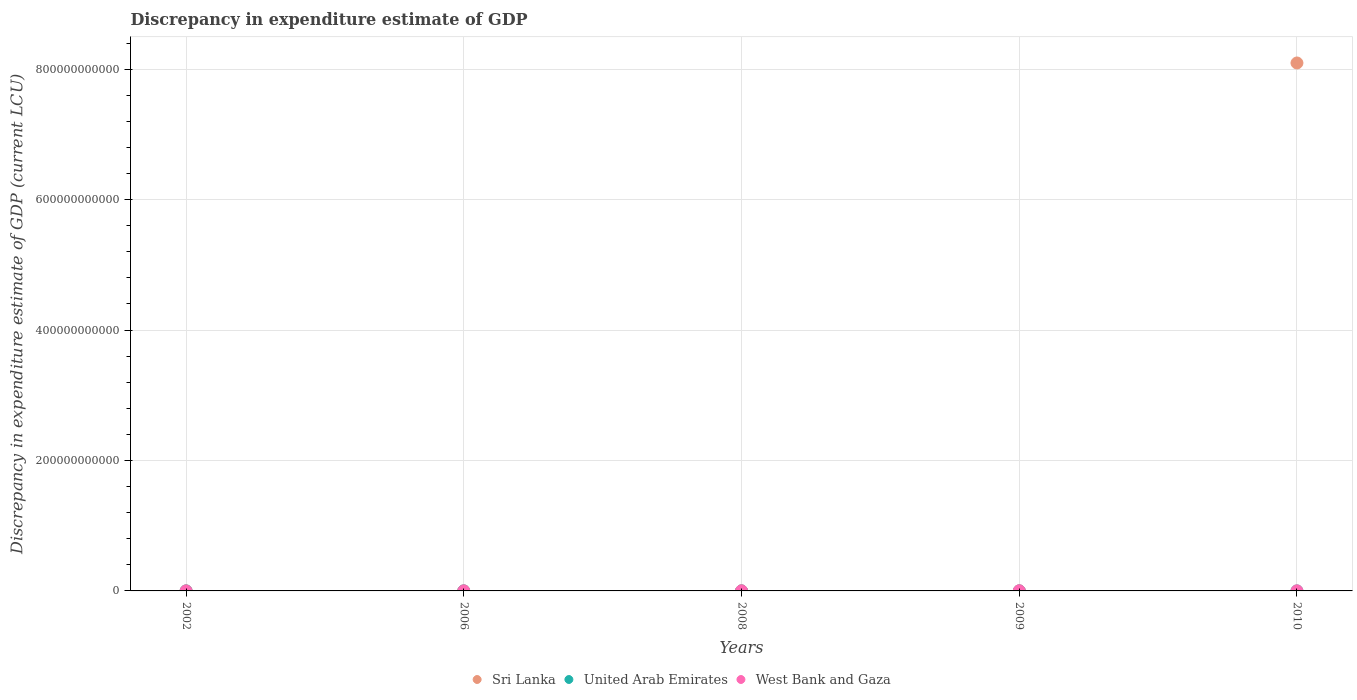How many different coloured dotlines are there?
Give a very brief answer. 3. What is the discrepancy in expenditure estimate of GDP in West Bank and Gaza in 2010?
Make the answer very short. 1.23e+08. Across all years, what is the maximum discrepancy in expenditure estimate of GDP in United Arab Emirates?
Offer a very short reply. 1.00e+06. Across all years, what is the minimum discrepancy in expenditure estimate of GDP in United Arab Emirates?
Make the answer very short. 0. In which year was the discrepancy in expenditure estimate of GDP in United Arab Emirates maximum?
Offer a very short reply. 2006. What is the total discrepancy in expenditure estimate of GDP in Sri Lanka in the graph?
Your answer should be compact. 8.10e+11. What is the difference between the discrepancy in expenditure estimate of GDP in West Bank and Gaza in 2006 and that in 2008?
Your response must be concise. -8.52e+07. What is the difference between the discrepancy in expenditure estimate of GDP in Sri Lanka in 2009 and the discrepancy in expenditure estimate of GDP in United Arab Emirates in 2008?
Keep it short and to the point. 1.00e+06. What is the average discrepancy in expenditure estimate of GDP in West Bank and Gaza per year?
Ensure brevity in your answer.  9.94e+07. In the year 2009, what is the difference between the discrepancy in expenditure estimate of GDP in West Bank and Gaza and discrepancy in expenditure estimate of GDP in Sri Lanka?
Ensure brevity in your answer.  2.21e+08. What is the ratio of the discrepancy in expenditure estimate of GDP in United Arab Emirates in 2002 to that in 2009?
Ensure brevity in your answer.  0.13. What is the difference between the highest and the second highest discrepancy in expenditure estimate of GDP in United Arab Emirates?
Offer a terse response. 1.00e+06. What is the difference between the highest and the lowest discrepancy in expenditure estimate of GDP in United Arab Emirates?
Keep it short and to the point. 1.00e+06. In how many years, is the discrepancy in expenditure estimate of GDP in West Bank and Gaza greater than the average discrepancy in expenditure estimate of GDP in West Bank and Gaza taken over all years?
Offer a very short reply. 3. Is it the case that in every year, the sum of the discrepancy in expenditure estimate of GDP in West Bank and Gaza and discrepancy in expenditure estimate of GDP in Sri Lanka  is greater than the discrepancy in expenditure estimate of GDP in United Arab Emirates?
Your answer should be compact. Yes. Does the discrepancy in expenditure estimate of GDP in West Bank and Gaza monotonically increase over the years?
Offer a very short reply. No. How many dotlines are there?
Your answer should be compact. 3. How many years are there in the graph?
Offer a terse response. 5. What is the difference between two consecutive major ticks on the Y-axis?
Make the answer very short. 2.00e+11. Are the values on the major ticks of Y-axis written in scientific E-notation?
Your answer should be compact. No. Does the graph contain grids?
Keep it short and to the point. Yes. Where does the legend appear in the graph?
Offer a terse response. Bottom center. What is the title of the graph?
Ensure brevity in your answer.  Discrepancy in expenditure estimate of GDP. What is the label or title of the Y-axis?
Make the answer very short. Discrepancy in expenditure estimate of GDP (current LCU). What is the Discrepancy in expenditure estimate of GDP (current LCU) in Sri Lanka in 2002?
Offer a terse response. 0. What is the Discrepancy in expenditure estimate of GDP (current LCU) in United Arab Emirates in 2002?
Provide a short and direct response. 3e-5. What is the Discrepancy in expenditure estimate of GDP (current LCU) of West Bank and Gaza in 2002?
Keep it short and to the point. 0. What is the Discrepancy in expenditure estimate of GDP (current LCU) in Sri Lanka in 2006?
Your answer should be compact. 0. What is the Discrepancy in expenditure estimate of GDP (current LCU) of United Arab Emirates in 2006?
Your response must be concise. 1.00e+06. What is the Discrepancy in expenditure estimate of GDP (current LCU) of West Bank and Gaza in 2006?
Keep it short and to the point. 3.30e+07. What is the Discrepancy in expenditure estimate of GDP (current LCU) in West Bank and Gaza in 2008?
Offer a very short reply. 1.18e+08. What is the Discrepancy in expenditure estimate of GDP (current LCU) of Sri Lanka in 2009?
Keep it short and to the point. 1.00e+06. What is the Discrepancy in expenditure estimate of GDP (current LCU) of United Arab Emirates in 2009?
Your response must be concise. 0. What is the Discrepancy in expenditure estimate of GDP (current LCU) in West Bank and Gaza in 2009?
Your response must be concise. 2.22e+08. What is the Discrepancy in expenditure estimate of GDP (current LCU) in Sri Lanka in 2010?
Give a very brief answer. 8.10e+11. What is the Discrepancy in expenditure estimate of GDP (current LCU) in West Bank and Gaza in 2010?
Give a very brief answer. 1.23e+08. Across all years, what is the maximum Discrepancy in expenditure estimate of GDP (current LCU) in Sri Lanka?
Keep it short and to the point. 8.10e+11. Across all years, what is the maximum Discrepancy in expenditure estimate of GDP (current LCU) in United Arab Emirates?
Give a very brief answer. 1.00e+06. Across all years, what is the maximum Discrepancy in expenditure estimate of GDP (current LCU) of West Bank and Gaza?
Ensure brevity in your answer.  2.22e+08. What is the total Discrepancy in expenditure estimate of GDP (current LCU) in Sri Lanka in the graph?
Your answer should be very brief. 8.10e+11. What is the total Discrepancy in expenditure estimate of GDP (current LCU) of United Arab Emirates in the graph?
Your answer should be very brief. 1.00e+06. What is the total Discrepancy in expenditure estimate of GDP (current LCU) of West Bank and Gaza in the graph?
Give a very brief answer. 4.97e+08. What is the difference between the Discrepancy in expenditure estimate of GDP (current LCU) in Sri Lanka in 2002 and that in 2006?
Your answer should be compact. -0. What is the difference between the Discrepancy in expenditure estimate of GDP (current LCU) of United Arab Emirates in 2002 and that in 2006?
Give a very brief answer. -1.00e+06. What is the difference between the Discrepancy in expenditure estimate of GDP (current LCU) of Sri Lanka in 2002 and that in 2009?
Provide a succinct answer. -1.00e+06. What is the difference between the Discrepancy in expenditure estimate of GDP (current LCU) in United Arab Emirates in 2002 and that in 2009?
Keep it short and to the point. -0. What is the difference between the Discrepancy in expenditure estimate of GDP (current LCU) in Sri Lanka in 2002 and that in 2010?
Offer a terse response. -8.10e+11. What is the difference between the Discrepancy in expenditure estimate of GDP (current LCU) of West Bank and Gaza in 2006 and that in 2008?
Provide a short and direct response. -8.52e+07. What is the difference between the Discrepancy in expenditure estimate of GDP (current LCU) in Sri Lanka in 2006 and that in 2009?
Your answer should be very brief. -1.00e+06. What is the difference between the Discrepancy in expenditure estimate of GDP (current LCU) in United Arab Emirates in 2006 and that in 2009?
Offer a very short reply. 1.00e+06. What is the difference between the Discrepancy in expenditure estimate of GDP (current LCU) in West Bank and Gaza in 2006 and that in 2009?
Provide a short and direct response. -1.89e+08. What is the difference between the Discrepancy in expenditure estimate of GDP (current LCU) of Sri Lanka in 2006 and that in 2010?
Provide a short and direct response. -8.10e+11. What is the difference between the Discrepancy in expenditure estimate of GDP (current LCU) in West Bank and Gaza in 2006 and that in 2010?
Keep it short and to the point. -9.05e+07. What is the difference between the Discrepancy in expenditure estimate of GDP (current LCU) in West Bank and Gaza in 2008 and that in 2009?
Your response must be concise. -1.04e+08. What is the difference between the Discrepancy in expenditure estimate of GDP (current LCU) in West Bank and Gaza in 2008 and that in 2010?
Provide a short and direct response. -5.23e+06. What is the difference between the Discrepancy in expenditure estimate of GDP (current LCU) of Sri Lanka in 2009 and that in 2010?
Your answer should be compact. -8.10e+11. What is the difference between the Discrepancy in expenditure estimate of GDP (current LCU) of West Bank and Gaza in 2009 and that in 2010?
Provide a succinct answer. 9.88e+07. What is the difference between the Discrepancy in expenditure estimate of GDP (current LCU) in Sri Lanka in 2002 and the Discrepancy in expenditure estimate of GDP (current LCU) in United Arab Emirates in 2006?
Provide a short and direct response. -1.00e+06. What is the difference between the Discrepancy in expenditure estimate of GDP (current LCU) of Sri Lanka in 2002 and the Discrepancy in expenditure estimate of GDP (current LCU) of West Bank and Gaza in 2006?
Your response must be concise. -3.30e+07. What is the difference between the Discrepancy in expenditure estimate of GDP (current LCU) in United Arab Emirates in 2002 and the Discrepancy in expenditure estimate of GDP (current LCU) in West Bank and Gaza in 2006?
Offer a very short reply. -3.30e+07. What is the difference between the Discrepancy in expenditure estimate of GDP (current LCU) of Sri Lanka in 2002 and the Discrepancy in expenditure estimate of GDP (current LCU) of West Bank and Gaza in 2008?
Offer a very short reply. -1.18e+08. What is the difference between the Discrepancy in expenditure estimate of GDP (current LCU) of United Arab Emirates in 2002 and the Discrepancy in expenditure estimate of GDP (current LCU) of West Bank and Gaza in 2008?
Your answer should be very brief. -1.18e+08. What is the difference between the Discrepancy in expenditure estimate of GDP (current LCU) of Sri Lanka in 2002 and the Discrepancy in expenditure estimate of GDP (current LCU) of United Arab Emirates in 2009?
Provide a succinct answer. -0. What is the difference between the Discrepancy in expenditure estimate of GDP (current LCU) in Sri Lanka in 2002 and the Discrepancy in expenditure estimate of GDP (current LCU) in West Bank and Gaza in 2009?
Offer a terse response. -2.22e+08. What is the difference between the Discrepancy in expenditure estimate of GDP (current LCU) of United Arab Emirates in 2002 and the Discrepancy in expenditure estimate of GDP (current LCU) of West Bank and Gaza in 2009?
Provide a short and direct response. -2.22e+08. What is the difference between the Discrepancy in expenditure estimate of GDP (current LCU) of Sri Lanka in 2002 and the Discrepancy in expenditure estimate of GDP (current LCU) of West Bank and Gaza in 2010?
Ensure brevity in your answer.  -1.23e+08. What is the difference between the Discrepancy in expenditure estimate of GDP (current LCU) of United Arab Emirates in 2002 and the Discrepancy in expenditure estimate of GDP (current LCU) of West Bank and Gaza in 2010?
Provide a succinct answer. -1.23e+08. What is the difference between the Discrepancy in expenditure estimate of GDP (current LCU) in Sri Lanka in 2006 and the Discrepancy in expenditure estimate of GDP (current LCU) in West Bank and Gaza in 2008?
Provide a short and direct response. -1.18e+08. What is the difference between the Discrepancy in expenditure estimate of GDP (current LCU) in United Arab Emirates in 2006 and the Discrepancy in expenditure estimate of GDP (current LCU) in West Bank and Gaza in 2008?
Ensure brevity in your answer.  -1.17e+08. What is the difference between the Discrepancy in expenditure estimate of GDP (current LCU) in Sri Lanka in 2006 and the Discrepancy in expenditure estimate of GDP (current LCU) in West Bank and Gaza in 2009?
Give a very brief answer. -2.22e+08. What is the difference between the Discrepancy in expenditure estimate of GDP (current LCU) of United Arab Emirates in 2006 and the Discrepancy in expenditure estimate of GDP (current LCU) of West Bank and Gaza in 2009?
Offer a terse response. -2.21e+08. What is the difference between the Discrepancy in expenditure estimate of GDP (current LCU) of Sri Lanka in 2006 and the Discrepancy in expenditure estimate of GDP (current LCU) of West Bank and Gaza in 2010?
Give a very brief answer. -1.23e+08. What is the difference between the Discrepancy in expenditure estimate of GDP (current LCU) in United Arab Emirates in 2006 and the Discrepancy in expenditure estimate of GDP (current LCU) in West Bank and Gaza in 2010?
Give a very brief answer. -1.22e+08. What is the difference between the Discrepancy in expenditure estimate of GDP (current LCU) of Sri Lanka in 2009 and the Discrepancy in expenditure estimate of GDP (current LCU) of West Bank and Gaza in 2010?
Provide a short and direct response. -1.22e+08. What is the difference between the Discrepancy in expenditure estimate of GDP (current LCU) in United Arab Emirates in 2009 and the Discrepancy in expenditure estimate of GDP (current LCU) in West Bank and Gaza in 2010?
Your answer should be very brief. -1.23e+08. What is the average Discrepancy in expenditure estimate of GDP (current LCU) in Sri Lanka per year?
Keep it short and to the point. 1.62e+11. What is the average Discrepancy in expenditure estimate of GDP (current LCU) in United Arab Emirates per year?
Your answer should be compact. 2.00e+05. What is the average Discrepancy in expenditure estimate of GDP (current LCU) of West Bank and Gaza per year?
Make the answer very short. 9.94e+07. In the year 2002, what is the difference between the Discrepancy in expenditure estimate of GDP (current LCU) of Sri Lanka and Discrepancy in expenditure estimate of GDP (current LCU) of United Arab Emirates?
Provide a succinct answer. 0. In the year 2006, what is the difference between the Discrepancy in expenditure estimate of GDP (current LCU) in Sri Lanka and Discrepancy in expenditure estimate of GDP (current LCU) in United Arab Emirates?
Provide a succinct answer. -1.00e+06. In the year 2006, what is the difference between the Discrepancy in expenditure estimate of GDP (current LCU) in Sri Lanka and Discrepancy in expenditure estimate of GDP (current LCU) in West Bank and Gaza?
Keep it short and to the point. -3.30e+07. In the year 2006, what is the difference between the Discrepancy in expenditure estimate of GDP (current LCU) of United Arab Emirates and Discrepancy in expenditure estimate of GDP (current LCU) of West Bank and Gaza?
Your response must be concise. -3.20e+07. In the year 2009, what is the difference between the Discrepancy in expenditure estimate of GDP (current LCU) in Sri Lanka and Discrepancy in expenditure estimate of GDP (current LCU) in United Arab Emirates?
Your answer should be compact. 1.00e+06. In the year 2009, what is the difference between the Discrepancy in expenditure estimate of GDP (current LCU) in Sri Lanka and Discrepancy in expenditure estimate of GDP (current LCU) in West Bank and Gaza?
Your response must be concise. -2.21e+08. In the year 2009, what is the difference between the Discrepancy in expenditure estimate of GDP (current LCU) in United Arab Emirates and Discrepancy in expenditure estimate of GDP (current LCU) in West Bank and Gaza?
Keep it short and to the point. -2.22e+08. In the year 2010, what is the difference between the Discrepancy in expenditure estimate of GDP (current LCU) of Sri Lanka and Discrepancy in expenditure estimate of GDP (current LCU) of West Bank and Gaza?
Provide a short and direct response. 8.09e+11. What is the ratio of the Discrepancy in expenditure estimate of GDP (current LCU) of United Arab Emirates in 2002 to that in 2006?
Offer a very short reply. 0. What is the ratio of the Discrepancy in expenditure estimate of GDP (current LCU) in Sri Lanka in 2002 to that in 2009?
Your response must be concise. 0. What is the ratio of the Discrepancy in expenditure estimate of GDP (current LCU) of United Arab Emirates in 2002 to that in 2009?
Offer a very short reply. 0.13. What is the ratio of the Discrepancy in expenditure estimate of GDP (current LCU) of West Bank and Gaza in 2006 to that in 2008?
Make the answer very short. 0.28. What is the ratio of the Discrepancy in expenditure estimate of GDP (current LCU) in Sri Lanka in 2006 to that in 2009?
Keep it short and to the point. 0. What is the ratio of the Discrepancy in expenditure estimate of GDP (current LCU) of United Arab Emirates in 2006 to that in 2009?
Offer a very short reply. 4.44e+09. What is the ratio of the Discrepancy in expenditure estimate of GDP (current LCU) in West Bank and Gaza in 2006 to that in 2009?
Your answer should be very brief. 0.15. What is the ratio of the Discrepancy in expenditure estimate of GDP (current LCU) in Sri Lanka in 2006 to that in 2010?
Make the answer very short. 0. What is the ratio of the Discrepancy in expenditure estimate of GDP (current LCU) of West Bank and Gaza in 2006 to that in 2010?
Offer a terse response. 0.27. What is the ratio of the Discrepancy in expenditure estimate of GDP (current LCU) of West Bank and Gaza in 2008 to that in 2009?
Your answer should be very brief. 0.53. What is the ratio of the Discrepancy in expenditure estimate of GDP (current LCU) of West Bank and Gaza in 2008 to that in 2010?
Your response must be concise. 0.96. What is the ratio of the Discrepancy in expenditure estimate of GDP (current LCU) in Sri Lanka in 2009 to that in 2010?
Offer a very short reply. 0. What is the ratio of the Discrepancy in expenditure estimate of GDP (current LCU) of West Bank and Gaza in 2009 to that in 2010?
Provide a short and direct response. 1.8. What is the difference between the highest and the second highest Discrepancy in expenditure estimate of GDP (current LCU) of Sri Lanka?
Provide a succinct answer. 8.10e+11. What is the difference between the highest and the second highest Discrepancy in expenditure estimate of GDP (current LCU) in United Arab Emirates?
Your answer should be very brief. 1.00e+06. What is the difference between the highest and the second highest Discrepancy in expenditure estimate of GDP (current LCU) in West Bank and Gaza?
Provide a succinct answer. 9.88e+07. What is the difference between the highest and the lowest Discrepancy in expenditure estimate of GDP (current LCU) of Sri Lanka?
Your answer should be compact. 8.10e+11. What is the difference between the highest and the lowest Discrepancy in expenditure estimate of GDP (current LCU) in West Bank and Gaza?
Keep it short and to the point. 2.22e+08. 